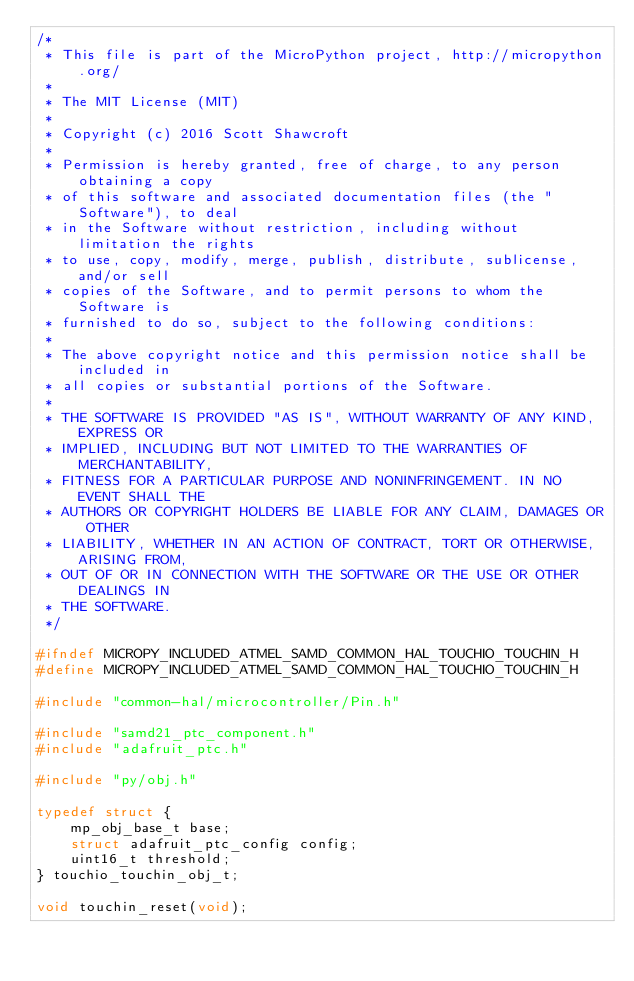Convert code to text. <code><loc_0><loc_0><loc_500><loc_500><_C_>/*
 * This file is part of the MicroPython project, http://micropython.org/
 *
 * The MIT License (MIT)
 *
 * Copyright (c) 2016 Scott Shawcroft
 *
 * Permission is hereby granted, free of charge, to any person obtaining a copy
 * of this software and associated documentation files (the "Software"), to deal
 * in the Software without restriction, including without limitation the rights
 * to use, copy, modify, merge, publish, distribute, sublicense, and/or sell
 * copies of the Software, and to permit persons to whom the Software is
 * furnished to do so, subject to the following conditions:
 *
 * The above copyright notice and this permission notice shall be included in
 * all copies or substantial portions of the Software.
 *
 * THE SOFTWARE IS PROVIDED "AS IS", WITHOUT WARRANTY OF ANY KIND, EXPRESS OR
 * IMPLIED, INCLUDING BUT NOT LIMITED TO THE WARRANTIES OF MERCHANTABILITY,
 * FITNESS FOR A PARTICULAR PURPOSE AND NONINFRINGEMENT. IN NO EVENT SHALL THE
 * AUTHORS OR COPYRIGHT HOLDERS BE LIABLE FOR ANY CLAIM, DAMAGES OR OTHER
 * LIABILITY, WHETHER IN AN ACTION OF CONTRACT, TORT OR OTHERWISE, ARISING FROM,
 * OUT OF OR IN CONNECTION WITH THE SOFTWARE OR THE USE OR OTHER DEALINGS IN
 * THE SOFTWARE.
 */

#ifndef MICROPY_INCLUDED_ATMEL_SAMD_COMMON_HAL_TOUCHIO_TOUCHIN_H
#define MICROPY_INCLUDED_ATMEL_SAMD_COMMON_HAL_TOUCHIO_TOUCHIN_H

#include "common-hal/microcontroller/Pin.h"

#include "samd21_ptc_component.h"
#include "adafruit_ptc.h"

#include "py/obj.h"

typedef struct {
    mp_obj_base_t base;
    struct adafruit_ptc_config config;
    uint16_t threshold;
} touchio_touchin_obj_t;

void touchin_reset(void);
</code> 